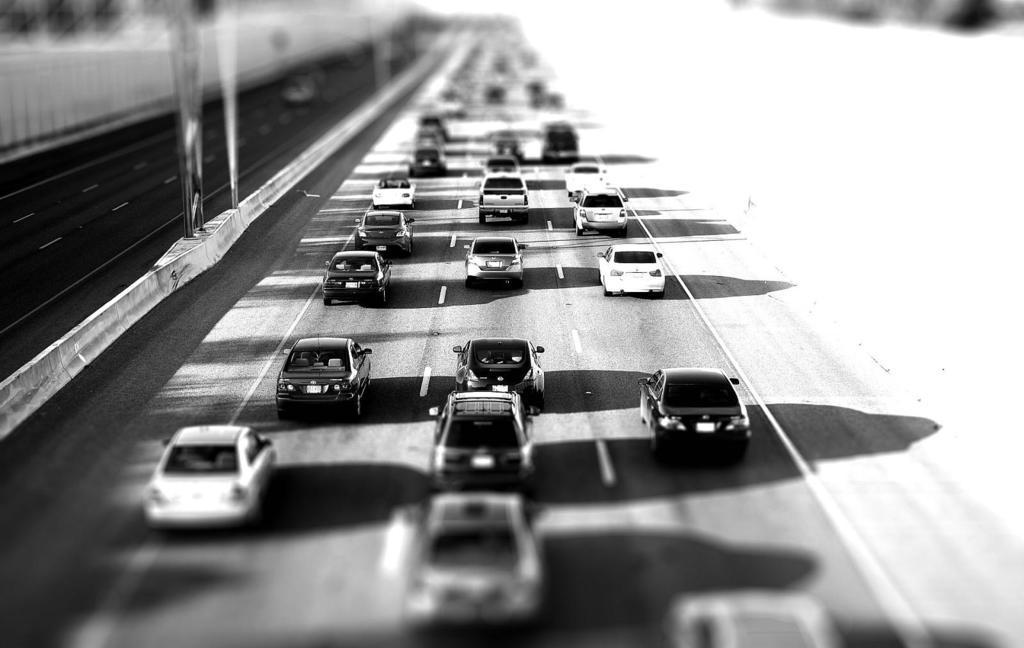Please provide a concise description of this image. This is a black and white picture. Here we can see roads, cars, and poles. There is a blur background. 